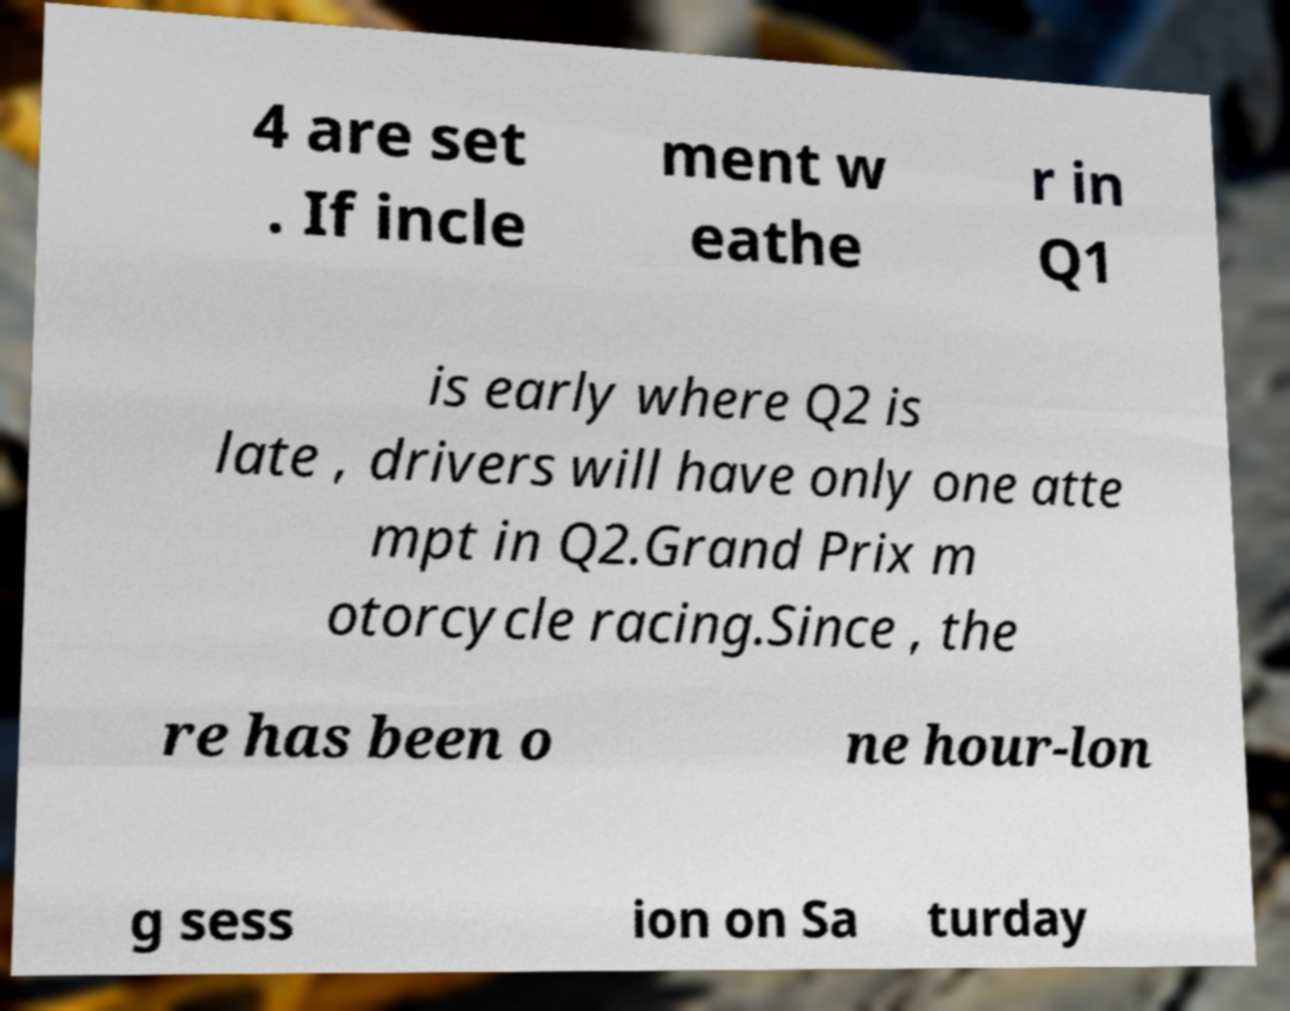I need the written content from this picture converted into text. Can you do that? 4 are set . If incle ment w eathe r in Q1 is early where Q2 is late , drivers will have only one atte mpt in Q2.Grand Prix m otorcycle racing.Since , the re has been o ne hour-lon g sess ion on Sa turday 